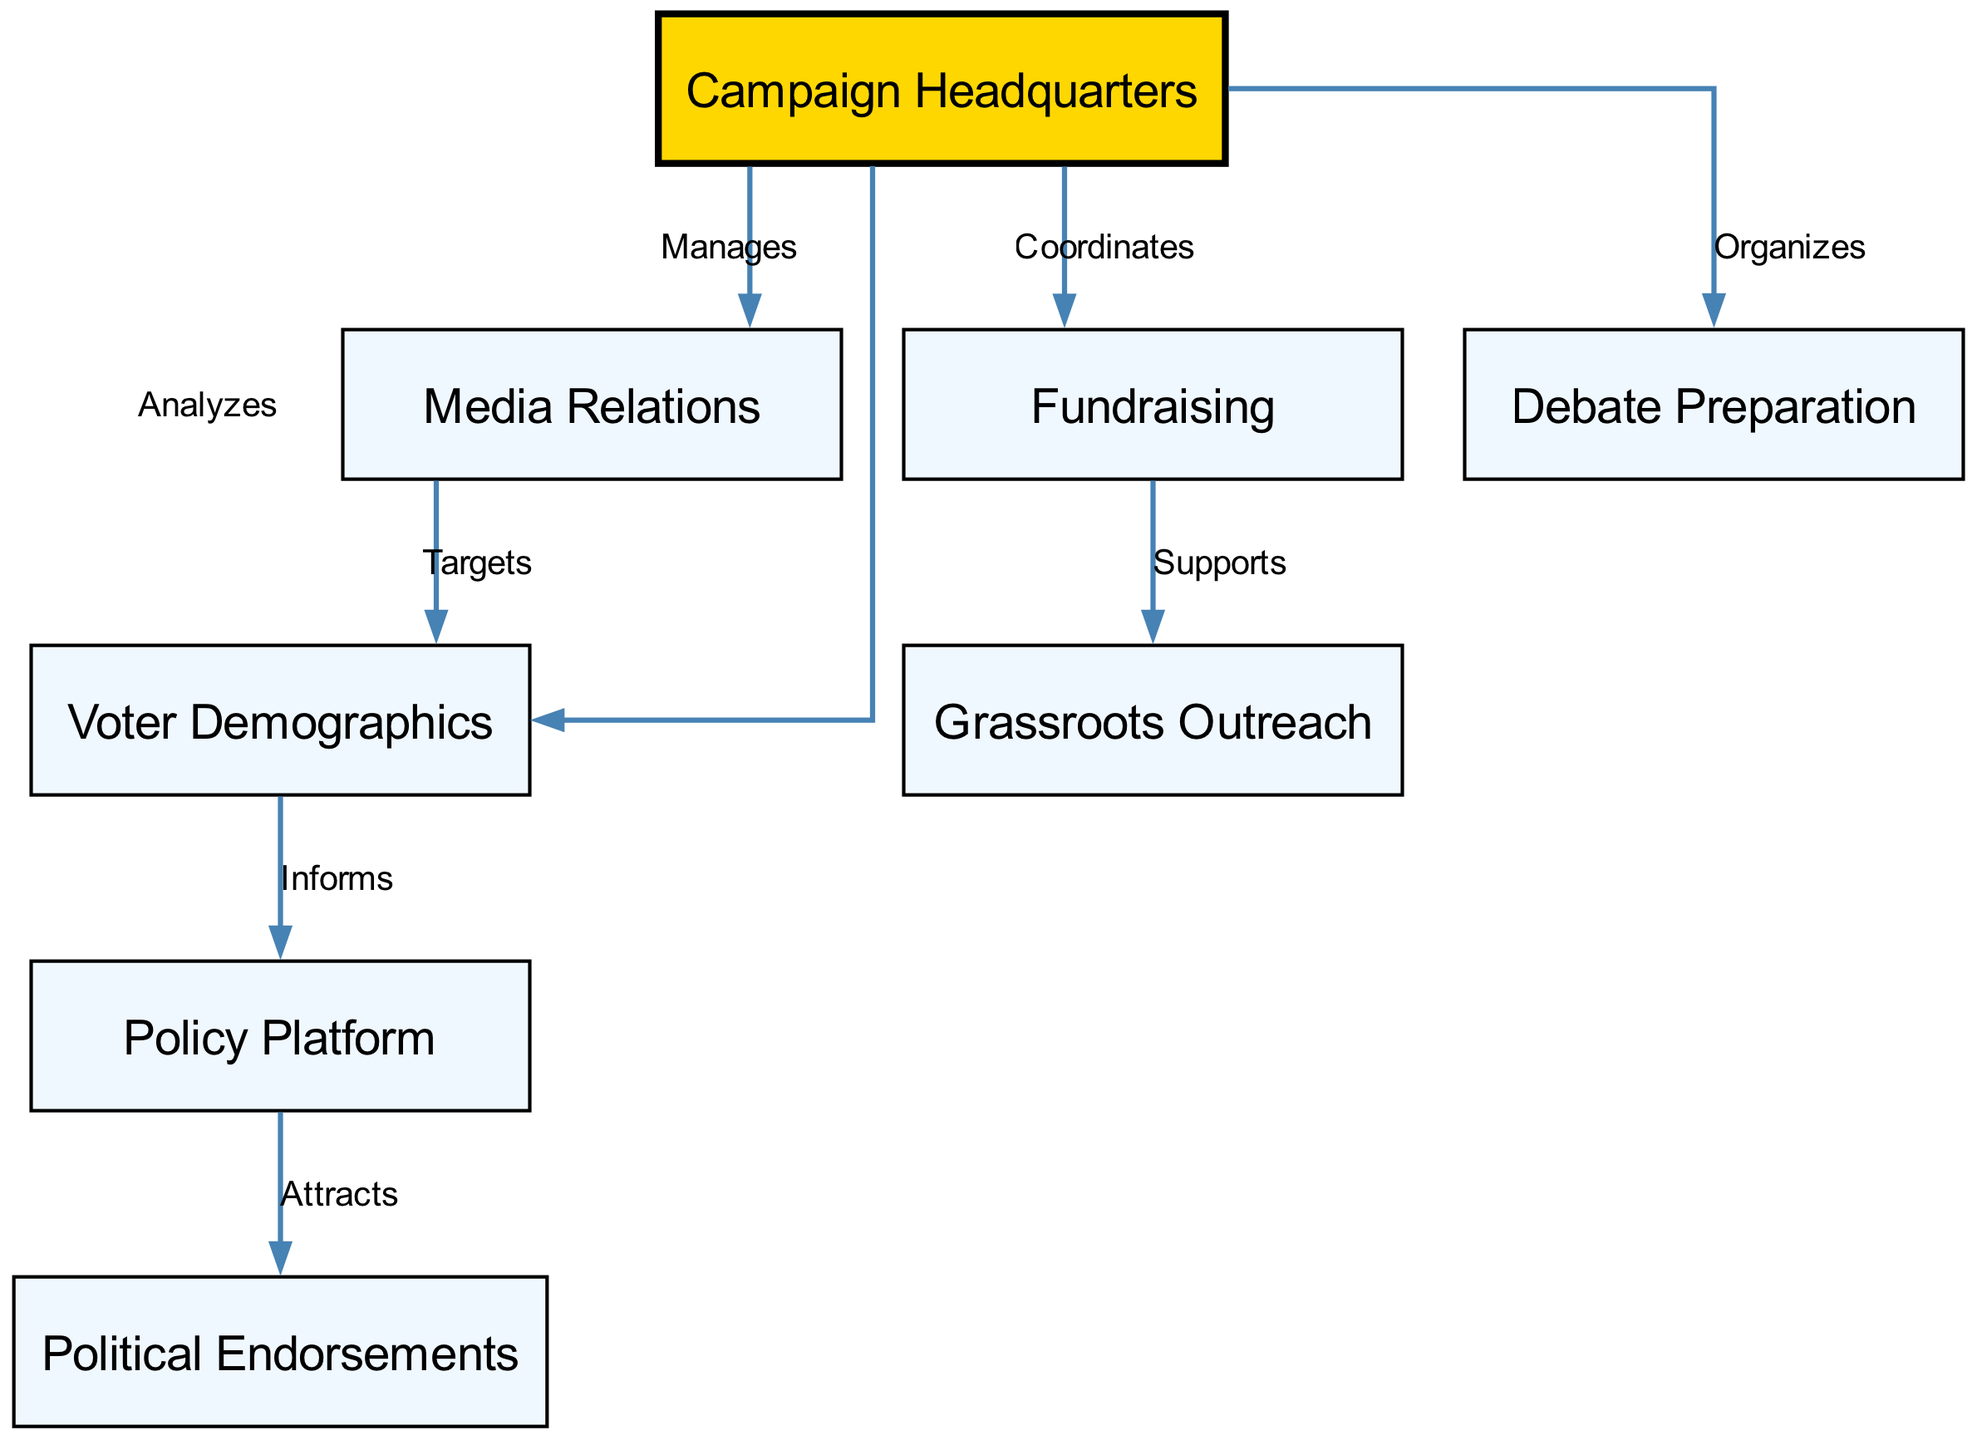What is the total number of nodes in the diagram? The diagram lists 8 distinct nodes related to the campaign strategy. These are "Campaign Headquarters," "Voter Demographics," "Policy Platform," "Media Relations," "Fundraising," "Grassroots Outreach," "Political Endorsements," and "Debate Preparation."
Answer: 8 What relationship exists between "Campaign Headquarters" and "Media Relations"? The edge connecting "Campaign Headquarters" to "Media Relations" is labeled "Manages," indicating that the Campaign Headquarters manages the Media Relations.
Answer: Manages Which node informs the "Policy Platform"? The edge from "Voter Demographics" to "Policy Platform" is labeled "Informs," indicating that the Voter Demographics provides information that shapes the Policy Platform.
Answer: Voter Demographics What is the role of "Fundraising" in relation to "Grassroots Outreach"? The edge from "Fundraising" to "Grassroots Outreach" is labeled "Supports," indicating that fundraising efforts aid or support grassroots outreach initiatives in the campaign strategy.
Answer: Supports How many edges are there in total? The diagram shows 8 connections (edges) between the nodes, reflecting the relationships and flow of information within the campaign strategy.
Answer: 8 Which nodes directly connect to the "Campaign Headquarters"? The edges lead from "Campaign Headquarters" to "Voter Demographics," "Media Relations," "Fundraising," and "Debate Preparation," showing that it connects directly to these four nodes.
Answer: Voter Demographics, Media Relations, Fundraising, Debate Preparation What does "Policy Platform" attract? The edge from "Policy Platform" to "Political Endorsements" is labeled "Attracts," indicating that the Policy Platform is designed to attract political endorsements.
Answer: Political Endorsements What is the relationship between "Media Relations" and "Voter Demographics"? The edge connecting "Media Relations" to "Voter Demographics" is labeled "Targets," suggesting that Media Relations targets specific segments of Voter Demographics in its outreach efforts.
Answer: Targets Which node is the focal point of the campaign and manages various aspects? "Campaign Headquarters" is the central node as it manages media relations, coordinates fundraising, organizes debate preparation, and analyzes voter demographics.
Answer: Campaign Headquarters 